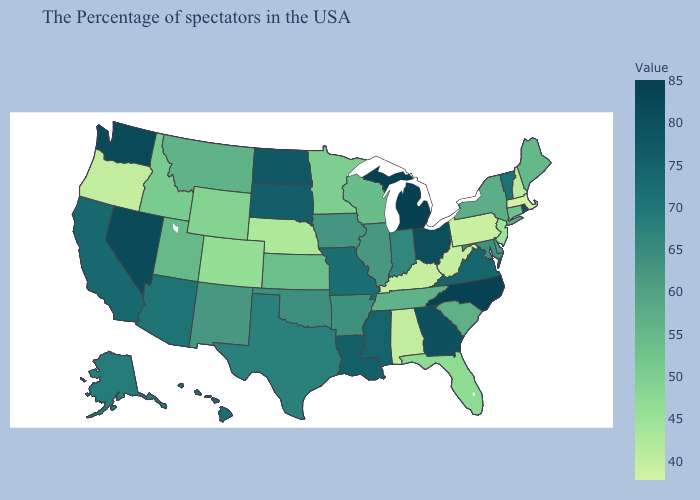Does Missouri have the highest value in the MidWest?
Write a very short answer. No. Does Washington have the highest value in the West?
Concise answer only. Yes. Does Rhode Island have the highest value in the Northeast?
Quick response, please. Yes. Does North Carolina have a lower value than Hawaii?
Short answer required. No. Among the states that border Montana , does Idaho have the lowest value?
Give a very brief answer. No. Among the states that border Arizona , does California have the highest value?
Keep it brief. No. 